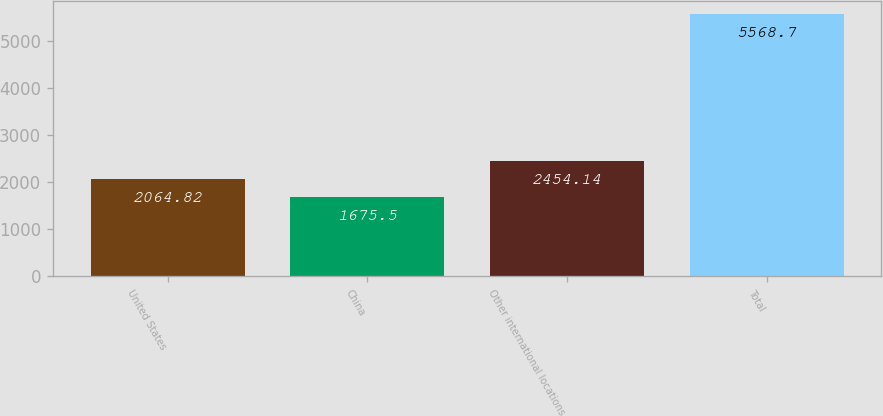Convert chart to OTSL. <chart><loc_0><loc_0><loc_500><loc_500><bar_chart><fcel>United States<fcel>China<fcel>Other international locations<fcel>Total<nl><fcel>2064.82<fcel>1675.5<fcel>2454.14<fcel>5568.7<nl></chart> 